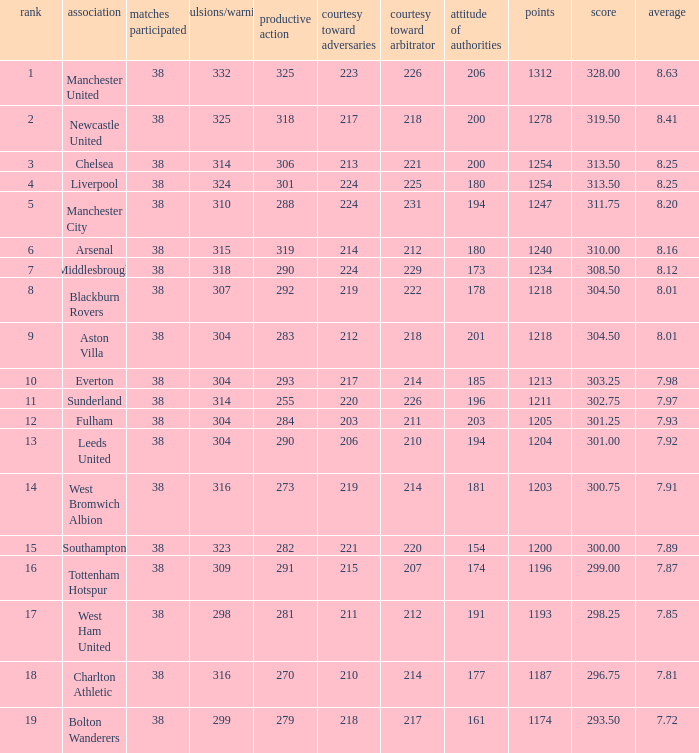Name the pos for west ham united 17.0. Could you parse the entire table? {'header': ['rank', 'association', 'matches participated', 'expulsions/warnings', 'productive action', 'courtesy toward adversaries', 'courtesy toward arbitrator', 'attitude of authorities', 'points', 'score', 'average'], 'rows': [['1', 'Manchester United', '38', '332', '325', '223', '226', '206', '1312', '328.00', '8.63'], ['2', 'Newcastle United', '38', '325', '318', '217', '218', '200', '1278', '319.50', '8.41'], ['3', 'Chelsea', '38', '314', '306', '213', '221', '200', '1254', '313.50', '8.25'], ['4', 'Liverpool', '38', '324', '301', '224', '225', '180', '1254', '313.50', '8.25'], ['5', 'Manchester City', '38', '310', '288', '224', '231', '194', '1247', '311.75', '8.20'], ['6', 'Arsenal', '38', '315', '319', '214', '212', '180', '1240', '310.00', '8.16'], ['7', 'Middlesbrough', '38', '318', '290', '224', '229', '173', '1234', '308.50', '8.12'], ['8', 'Blackburn Rovers', '38', '307', '292', '219', '222', '178', '1218', '304.50', '8.01'], ['9', 'Aston Villa', '38', '304', '283', '212', '218', '201', '1218', '304.50', '8.01'], ['10', 'Everton', '38', '304', '293', '217', '214', '185', '1213', '303.25', '7.98'], ['11', 'Sunderland', '38', '314', '255', '220', '226', '196', '1211', '302.75', '7.97'], ['12', 'Fulham', '38', '304', '284', '203', '211', '203', '1205', '301.25', '7.93'], ['13', 'Leeds United', '38', '304', '290', '206', '210', '194', '1204', '301.00', '7.92'], ['14', 'West Bromwich Albion', '38', '316', '273', '219', '214', '181', '1203', '300.75', '7.91'], ['15', 'Southampton', '38', '323', '282', '221', '220', '154', '1200', '300.00', '7.89'], ['16', 'Tottenham Hotspur', '38', '309', '291', '215', '207', '174', '1196', '299.00', '7.87'], ['17', 'West Ham United', '38', '298', '281', '211', '212', '191', '1193', '298.25', '7.85'], ['18', 'Charlton Athletic', '38', '316', '270', '210', '214', '177', '1187', '296.75', '7.81'], ['19', 'Bolton Wanderers', '38', '299', '279', '218', '217', '161', '1174', '293.50', '7.72']]} 